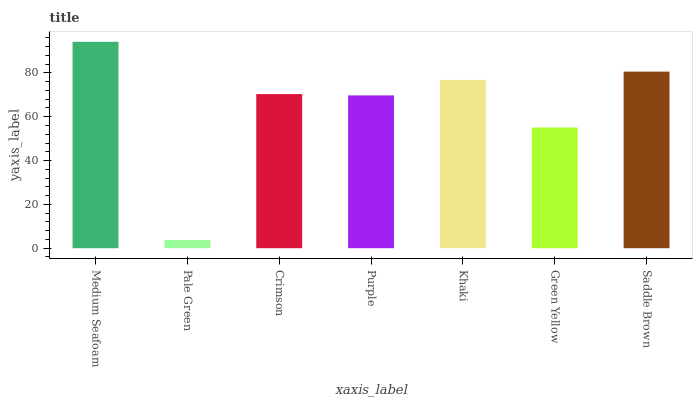Is Pale Green the minimum?
Answer yes or no. Yes. Is Medium Seafoam the maximum?
Answer yes or no. Yes. Is Crimson the minimum?
Answer yes or no. No. Is Crimson the maximum?
Answer yes or no. No. Is Crimson greater than Pale Green?
Answer yes or no. Yes. Is Pale Green less than Crimson?
Answer yes or no. Yes. Is Pale Green greater than Crimson?
Answer yes or no. No. Is Crimson less than Pale Green?
Answer yes or no. No. Is Crimson the high median?
Answer yes or no. Yes. Is Crimson the low median?
Answer yes or no. Yes. Is Khaki the high median?
Answer yes or no. No. Is Medium Seafoam the low median?
Answer yes or no. No. 